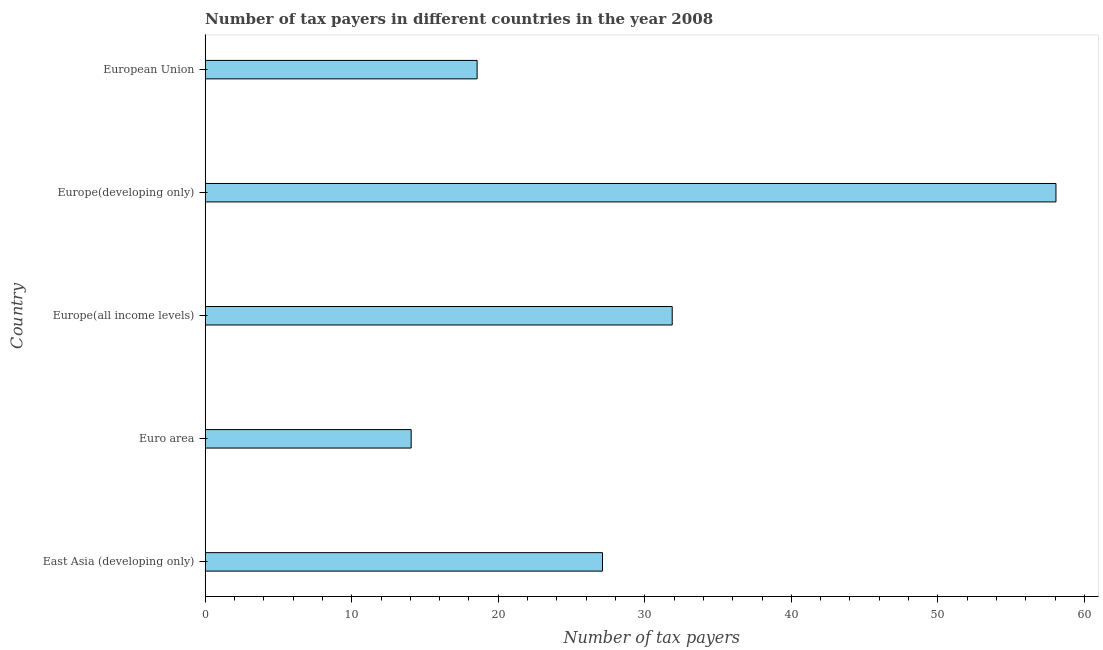What is the title of the graph?
Provide a short and direct response. Number of tax payers in different countries in the year 2008. What is the label or title of the X-axis?
Your answer should be very brief. Number of tax payers. What is the number of tax payers in Europe(developing only)?
Your answer should be very brief. 58.06. Across all countries, what is the maximum number of tax payers?
Your response must be concise. 58.06. Across all countries, what is the minimum number of tax payers?
Make the answer very short. 14.06. In which country was the number of tax payers maximum?
Keep it short and to the point. Europe(developing only). What is the sum of the number of tax payers?
Your response must be concise. 149.65. What is the difference between the number of tax payers in East Asia (developing only) and Euro area?
Your answer should be very brief. 13.06. What is the average number of tax payers per country?
Ensure brevity in your answer.  29.93. What is the median number of tax payers?
Give a very brief answer. 27.11. What is the ratio of the number of tax payers in Europe(all income levels) to that in European Union?
Ensure brevity in your answer.  1.72. Is the number of tax payers in East Asia (developing only) less than that in European Union?
Offer a very short reply. No. What is the difference between the highest and the second highest number of tax payers?
Your answer should be very brief. 26.19. Is the sum of the number of tax payers in Euro area and European Union greater than the maximum number of tax payers across all countries?
Provide a succinct answer. No. What is the difference between the highest and the lowest number of tax payers?
Provide a short and direct response. 44. Are all the bars in the graph horizontal?
Give a very brief answer. Yes. How many countries are there in the graph?
Your response must be concise. 5. What is the Number of tax payers of East Asia (developing only)?
Provide a short and direct response. 27.11. What is the Number of tax payers in Euro area?
Provide a succinct answer. 14.06. What is the Number of tax payers in Europe(all income levels)?
Your response must be concise. 31.87. What is the Number of tax payers of Europe(developing only)?
Your response must be concise. 58.06. What is the Number of tax payers of European Union?
Offer a terse response. 18.56. What is the difference between the Number of tax payers in East Asia (developing only) and Euro area?
Give a very brief answer. 13.06. What is the difference between the Number of tax payers in East Asia (developing only) and Europe(all income levels)?
Ensure brevity in your answer.  -4.76. What is the difference between the Number of tax payers in East Asia (developing only) and Europe(developing only)?
Keep it short and to the point. -30.94. What is the difference between the Number of tax payers in East Asia (developing only) and European Union?
Provide a short and direct response. 8.56. What is the difference between the Number of tax payers in Euro area and Europe(all income levels)?
Your answer should be compact. -17.81. What is the difference between the Number of tax payers in Euro area and Europe(developing only)?
Provide a short and direct response. -44. What is the difference between the Number of tax payers in Europe(all income levels) and Europe(developing only)?
Offer a very short reply. -26.19. What is the difference between the Number of tax payers in Europe(all income levels) and European Union?
Keep it short and to the point. 13.31. What is the difference between the Number of tax payers in Europe(developing only) and European Union?
Make the answer very short. 39.5. What is the ratio of the Number of tax payers in East Asia (developing only) to that in Euro area?
Your answer should be compact. 1.93. What is the ratio of the Number of tax payers in East Asia (developing only) to that in Europe(all income levels)?
Make the answer very short. 0.85. What is the ratio of the Number of tax payers in East Asia (developing only) to that in Europe(developing only)?
Your response must be concise. 0.47. What is the ratio of the Number of tax payers in East Asia (developing only) to that in European Union?
Offer a very short reply. 1.46. What is the ratio of the Number of tax payers in Euro area to that in Europe(all income levels)?
Give a very brief answer. 0.44. What is the ratio of the Number of tax payers in Euro area to that in Europe(developing only)?
Provide a short and direct response. 0.24. What is the ratio of the Number of tax payers in Euro area to that in European Union?
Make the answer very short. 0.76. What is the ratio of the Number of tax payers in Europe(all income levels) to that in Europe(developing only)?
Offer a terse response. 0.55. What is the ratio of the Number of tax payers in Europe(all income levels) to that in European Union?
Your answer should be very brief. 1.72. What is the ratio of the Number of tax payers in Europe(developing only) to that in European Union?
Ensure brevity in your answer.  3.13. 